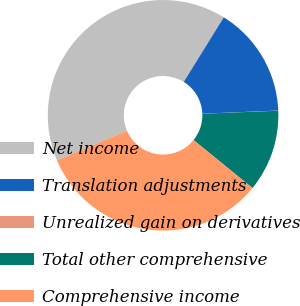<chart> <loc_0><loc_0><loc_500><loc_500><pie_chart><fcel>Net income<fcel>Translation adjustments<fcel>Unrealized gain on derivatives<fcel>Total other comprehensive<fcel>Comprehensive income<nl><fcel>40.22%<fcel>15.52%<fcel>0.02%<fcel>11.5%<fcel>32.74%<nl></chart> 